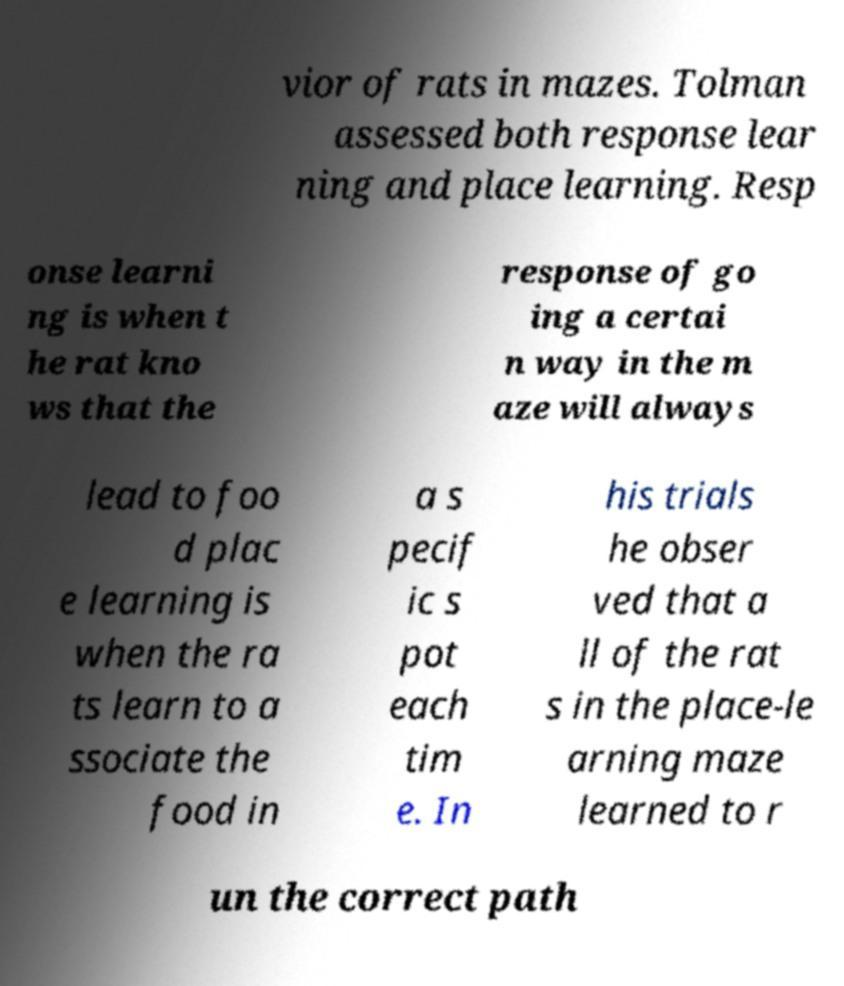For documentation purposes, I need the text within this image transcribed. Could you provide that? vior of rats in mazes. Tolman assessed both response lear ning and place learning. Resp onse learni ng is when t he rat kno ws that the response of go ing a certai n way in the m aze will always lead to foo d plac e learning is when the ra ts learn to a ssociate the food in a s pecif ic s pot each tim e. In his trials he obser ved that a ll of the rat s in the place-le arning maze learned to r un the correct path 